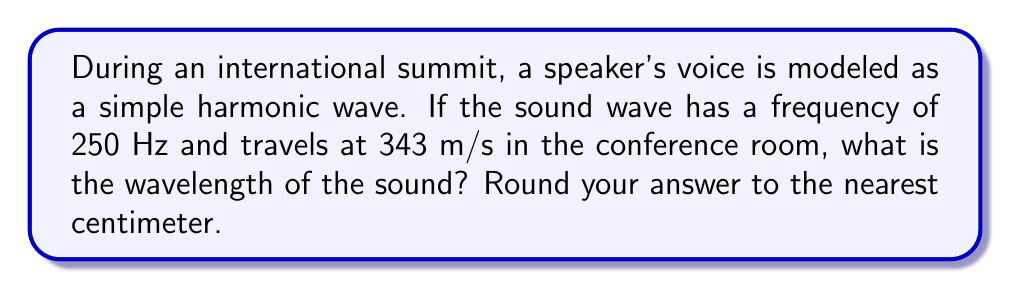What is the answer to this math problem? To solve this problem, we'll use the wave equation that relates wave speed, frequency, and wavelength:

$$v = f \lambda$$

Where:
$v$ is the wave speed (in m/s)
$f$ is the frequency (in Hz)
$\lambda$ is the wavelength (in m)

Given:
- Frequency, $f = 250$ Hz
- Wave speed, $v = 343$ m/s

Step 1: Rearrange the wave equation to solve for wavelength:
$$\lambda = \frac{v}{f}$$

Step 2: Substitute the known values:
$$\lambda = \frac{343 \text{ m/s}}{250 \text{ Hz}}$$

Step 3: Calculate the wavelength:
$$\lambda = 1.372 \text{ m}$$

Step 4: Convert to centimeters and round to the nearest centimeter:
$$\lambda = 1.372 \text{ m} \times 100 \text{ cm/m} = 137.2 \text{ cm} \approx 137 \text{ cm}$$
Answer: 137 cm 